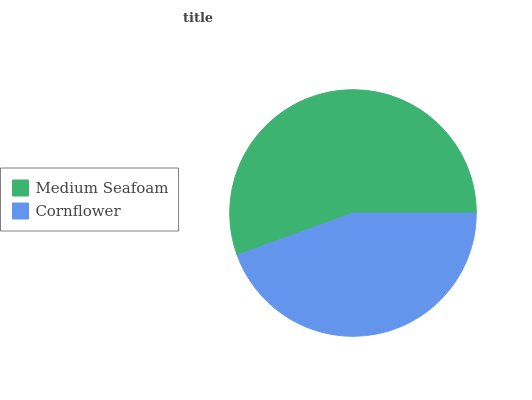Is Cornflower the minimum?
Answer yes or no. Yes. Is Medium Seafoam the maximum?
Answer yes or no. Yes. Is Cornflower the maximum?
Answer yes or no. No. Is Medium Seafoam greater than Cornflower?
Answer yes or no. Yes. Is Cornflower less than Medium Seafoam?
Answer yes or no. Yes. Is Cornflower greater than Medium Seafoam?
Answer yes or no. No. Is Medium Seafoam less than Cornflower?
Answer yes or no. No. Is Medium Seafoam the high median?
Answer yes or no. Yes. Is Cornflower the low median?
Answer yes or no. Yes. Is Cornflower the high median?
Answer yes or no. No. Is Medium Seafoam the low median?
Answer yes or no. No. 